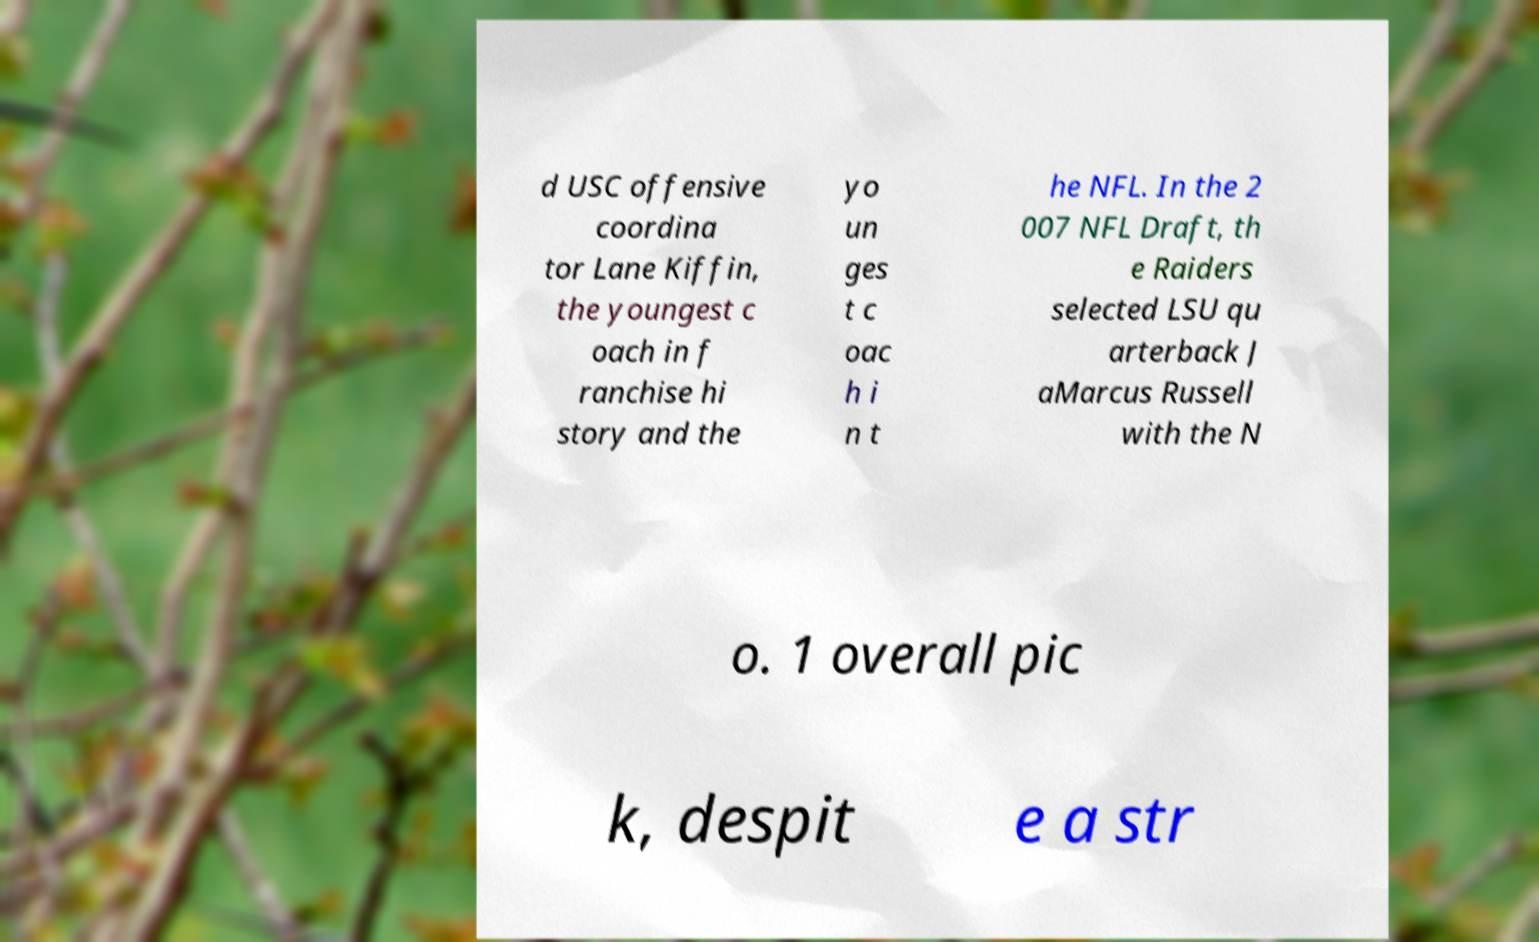Could you extract and type out the text from this image? d USC offensive coordina tor Lane Kiffin, the youngest c oach in f ranchise hi story and the yo un ges t c oac h i n t he NFL. In the 2 007 NFL Draft, th e Raiders selected LSU qu arterback J aMarcus Russell with the N o. 1 overall pic k, despit e a str 